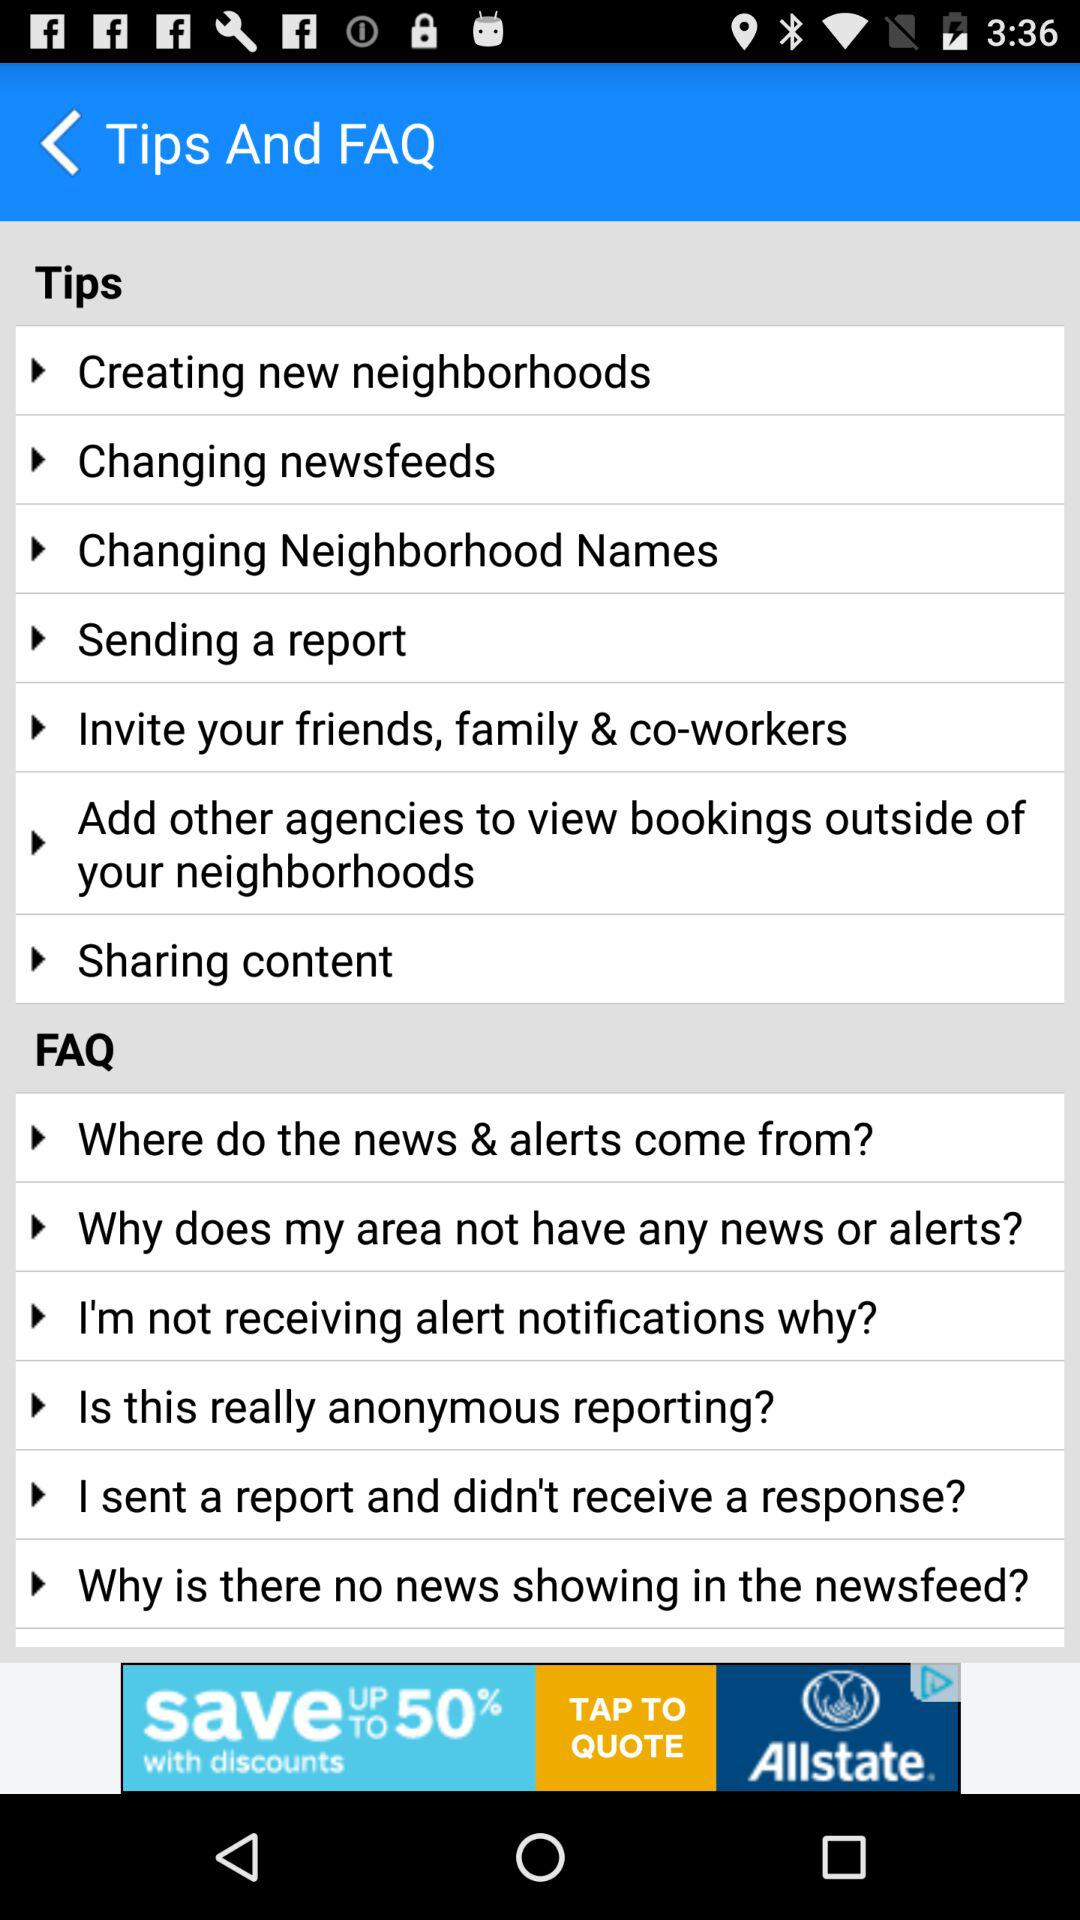What exactly are the contents of the FAQs? The contents of the FAQs are exactly "Where do the news & alerts come from?", "Why does my area not have any news or alerts?", "I'm not receiving alert notifications why?", "Is this really anonymous reporting?", "I sent a report and didn't receive a response?" and "Why is there no news showing in the newsfeed?". 